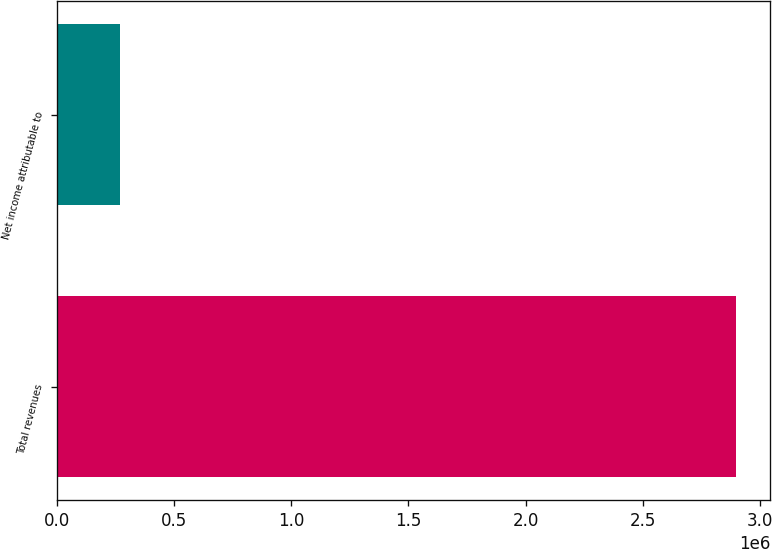Convert chart. <chart><loc_0><loc_0><loc_500><loc_500><bar_chart><fcel>Total revenues<fcel>Net income attributable to<nl><fcel>2.89815e+06<fcel>271666<nl></chart> 